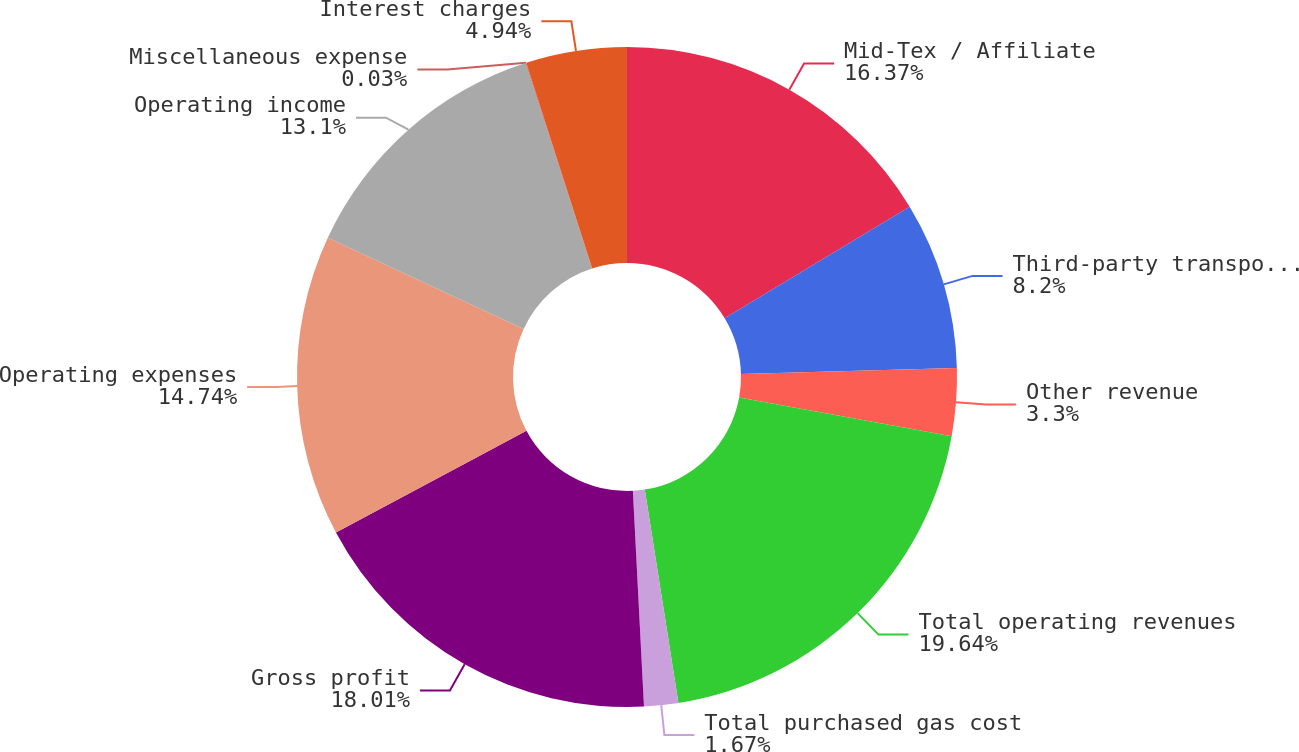Convert chart to OTSL. <chart><loc_0><loc_0><loc_500><loc_500><pie_chart><fcel>Mid-Tex / Affiliate<fcel>Third-party transportation<fcel>Other revenue<fcel>Total operating revenues<fcel>Total purchased gas cost<fcel>Gross profit<fcel>Operating expenses<fcel>Operating income<fcel>Miscellaneous expense<fcel>Interest charges<nl><fcel>16.37%<fcel>8.2%<fcel>3.3%<fcel>19.64%<fcel>1.67%<fcel>18.01%<fcel>14.74%<fcel>13.1%<fcel>0.03%<fcel>4.94%<nl></chart> 